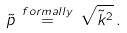<formula> <loc_0><loc_0><loc_500><loc_500>\tilde { p } \, \stackrel { f o r m a l l y } { = } \, \sqrt { \tilde { k } ^ { 2 } } \, .</formula> 